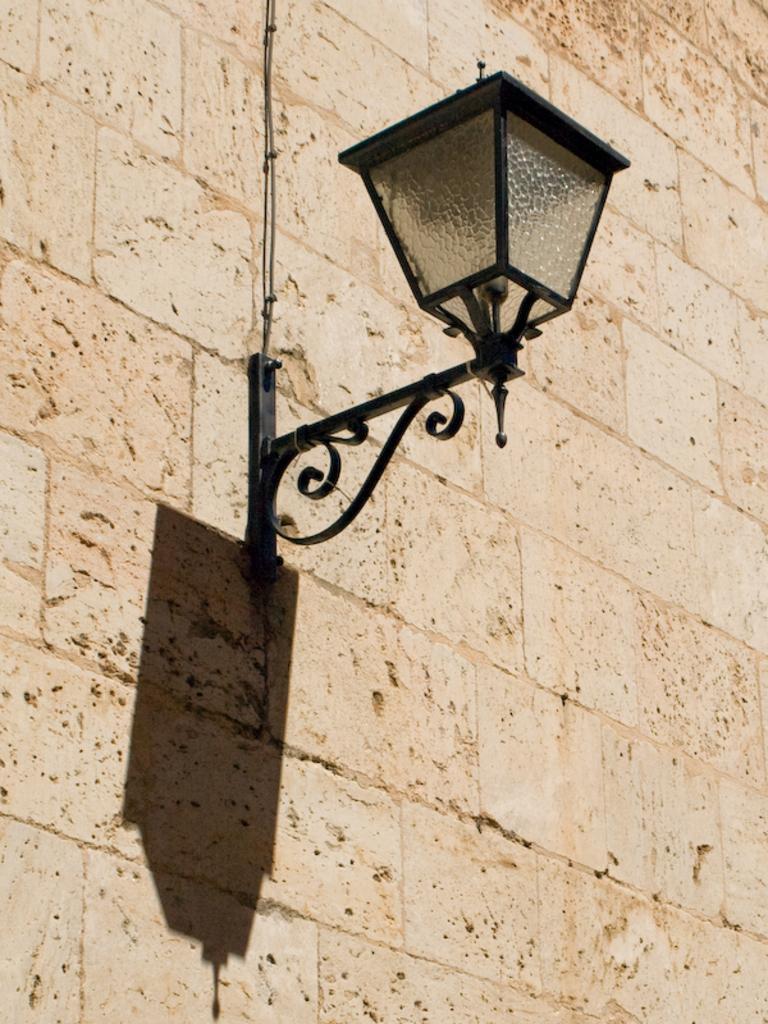Can you describe this image briefly? In this image we can see wall and an electric light attached to it. 